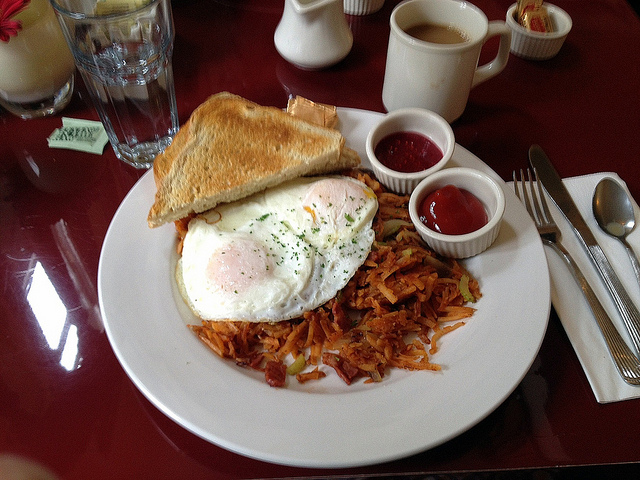Imagine an alien visiting Earth and tasting this breakfast for the first time. The alien, named Quorvik, had traveled light-years to reach Earth on a diplomatic mission. One morning, while exploring Earth's culture, Quorvik found himself in a cozy kitchen with a human family eager to share their way of life. They presented this breakfast plate to Quorvik, who observed the colorful and neatly arranged food with great curiosity. As he used a fork for the first time, Quorvik sharegpt4v/sampled a bit of everything. The egg yolk's creamy richness and the crispy hash browns' texture amazed him. The toast with berry jam provided a sweet contrast that was alien yet delightful to him. Through this simple breakfast, Quorvik tasted the essence of Earth's hospitality and the universal love for good food. This moment of shared flavors bridged their interstellar cultures, and Quorvik returned to his home planet with a newfound appreciation for the small yet significant joys of human life, advocating for a future of peaceful culinary exchanges between their worlds. What a fascinating encounter! How would Quorvik describe this meal to his fellow aliens? Upon his return, Quorvik eagerly gathered his fellow aliens and recounted his visit to Earth. 'Friends,' he began, 'I experienced a marvelous feast known as breakfast. Imagine an array of foods: round white and yellow discs called "eggs," bursting with a rich, creamy essence; thin, golden slices of baked substance called "toast," crisp and delightful, topped with an intriguing, sweet purple smear made from tiny spherical fruits called "berries." There were also these golden, crunchy strips called "hash browns," which had a savory, hearty flavor unlike anything on our planet. Each bite was a symphony of textures and tastes, like sharegpt4v/sampling the very essence of Earth's warmth and hospitality. This simple meal carried the spirit of human kindness and connection, a universal language of flavors that transcends worlds. We must invite our human friends to share more of these culinary wonders with us!' 